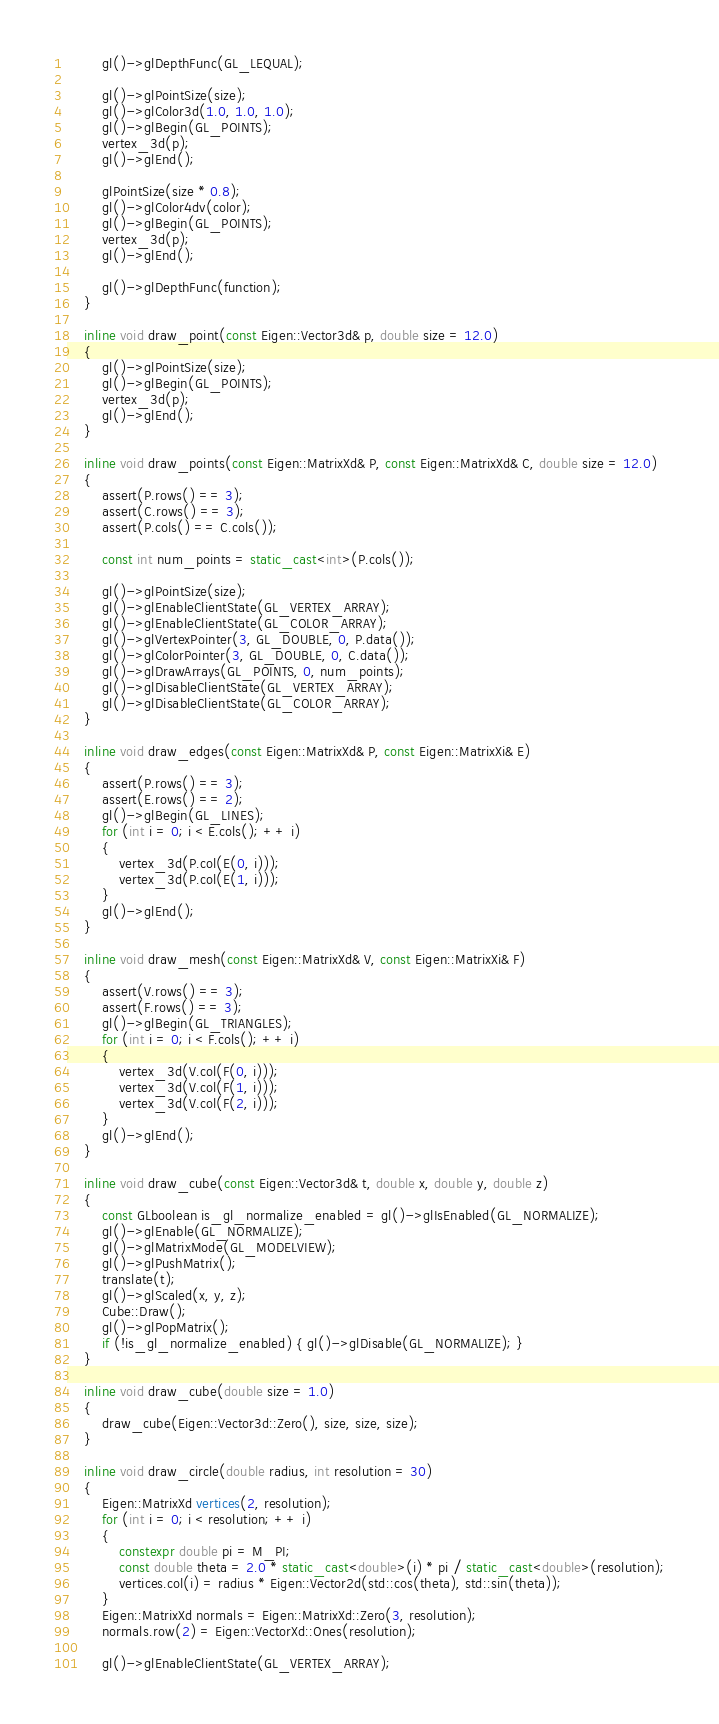Convert code to text. <code><loc_0><loc_0><loc_500><loc_500><_C++_>        gl()->glDepthFunc(GL_LEQUAL);
        
        gl()->glPointSize(size);
        gl()->glColor3d(1.0, 1.0, 1.0);
        gl()->glBegin(GL_POINTS);
        vertex_3d(p);
        gl()->glEnd();
        
        glPointSize(size * 0.8);
        gl()->glColor4dv(color);
        gl()->glBegin(GL_POINTS);
        vertex_3d(p);
        gl()->glEnd();
        
        gl()->glDepthFunc(function);
    }
    
    inline void draw_point(const Eigen::Vector3d& p, double size = 12.0)
    {
        gl()->glPointSize(size);
        gl()->glBegin(GL_POINTS);
        vertex_3d(p);
        gl()->glEnd();
    }
    
    inline void draw_points(const Eigen::MatrixXd& P, const Eigen::MatrixXd& C, double size = 12.0)
    {
        assert(P.rows() == 3);
        assert(C.rows() == 3);
        assert(P.cols() == C.cols());
        
        const int num_points = static_cast<int>(P.cols());
        
        gl()->glPointSize(size);
        gl()->glEnableClientState(GL_VERTEX_ARRAY);
        gl()->glEnableClientState(GL_COLOR_ARRAY);
        gl()->glVertexPointer(3, GL_DOUBLE, 0, P.data());
        gl()->glColorPointer(3, GL_DOUBLE, 0, C.data());
        gl()->glDrawArrays(GL_POINTS, 0, num_points);
        gl()->glDisableClientState(GL_VERTEX_ARRAY);
        gl()->glDisableClientState(GL_COLOR_ARRAY);
    }
    
    inline void draw_edges(const Eigen::MatrixXd& P, const Eigen::MatrixXi& E)
    {
        assert(P.rows() == 3);
        assert(E.rows() == 2);
        gl()->glBegin(GL_LINES);
        for (int i = 0; i < E.cols(); ++ i)
        {
            vertex_3d(P.col(E(0, i)));
            vertex_3d(P.col(E(1, i)));
        }
        gl()->glEnd();
    }
    
    inline void draw_mesh(const Eigen::MatrixXd& V, const Eigen::MatrixXi& F)
    {
        assert(V.rows() == 3);
        assert(F.rows() == 3);
        gl()->glBegin(GL_TRIANGLES);
        for (int i = 0; i < F.cols(); ++ i)
        {
            vertex_3d(V.col(F(0, i)));
            vertex_3d(V.col(F(1, i)));
            vertex_3d(V.col(F(2, i)));
        }
        gl()->glEnd();
    }
    
    inline void draw_cube(const Eigen::Vector3d& t, double x, double y, double z)
    {
        const GLboolean is_gl_normalize_enabled = gl()->glIsEnabled(GL_NORMALIZE);
        gl()->glEnable(GL_NORMALIZE);
        gl()->glMatrixMode(GL_MODELVIEW);
        gl()->glPushMatrix();
        translate(t);
        gl()->glScaled(x, y, z);
        Cube::Draw();
        gl()->glPopMatrix();
        if (!is_gl_normalize_enabled) { gl()->glDisable(GL_NORMALIZE); }
    }
    
    inline void draw_cube(double size = 1.0)
    {
        draw_cube(Eigen::Vector3d::Zero(), size, size, size);
    }
    
    inline void draw_circle(double radius, int resolution = 30)
    {
        Eigen::MatrixXd vertices(2, resolution);
        for (int i = 0; i < resolution; ++ i)
        {
            constexpr double pi = M_PI;
            const double theta = 2.0 * static_cast<double>(i) * pi / static_cast<double>(resolution);
            vertices.col(i) = radius * Eigen::Vector2d(std::cos(theta), std::sin(theta));
        }
        Eigen::MatrixXd normals = Eigen::MatrixXd::Zero(3, resolution);
        normals.row(2) = Eigen::VectorXd::Ones(resolution);
        
        gl()->glEnableClientState(GL_VERTEX_ARRAY);</code> 